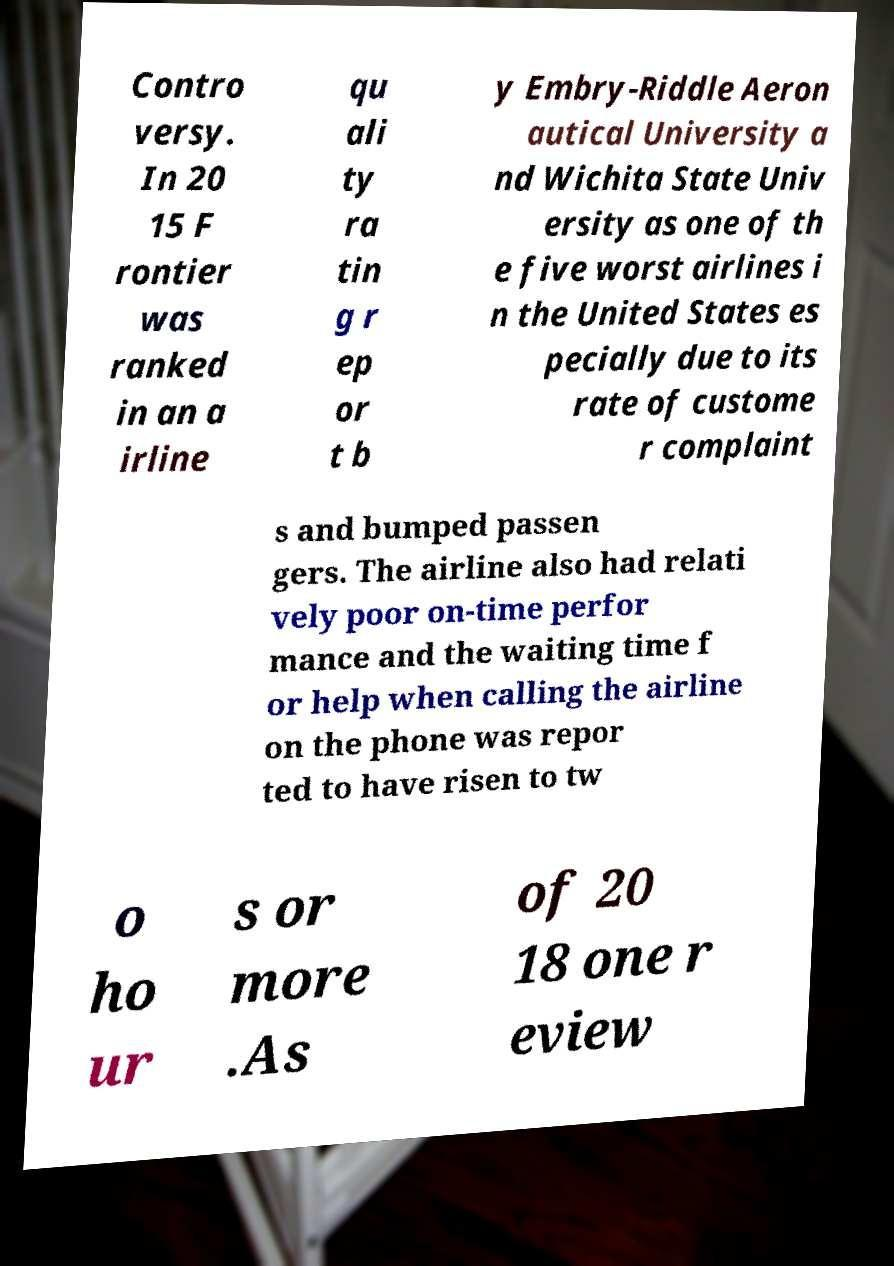Please identify and transcribe the text found in this image. Contro versy. In 20 15 F rontier was ranked in an a irline qu ali ty ra tin g r ep or t b y Embry-Riddle Aeron autical University a nd Wichita State Univ ersity as one of th e five worst airlines i n the United States es pecially due to its rate of custome r complaint s and bumped passen gers. The airline also had relati vely poor on-time perfor mance and the waiting time f or help when calling the airline on the phone was repor ted to have risen to tw o ho ur s or more .As of 20 18 one r eview 